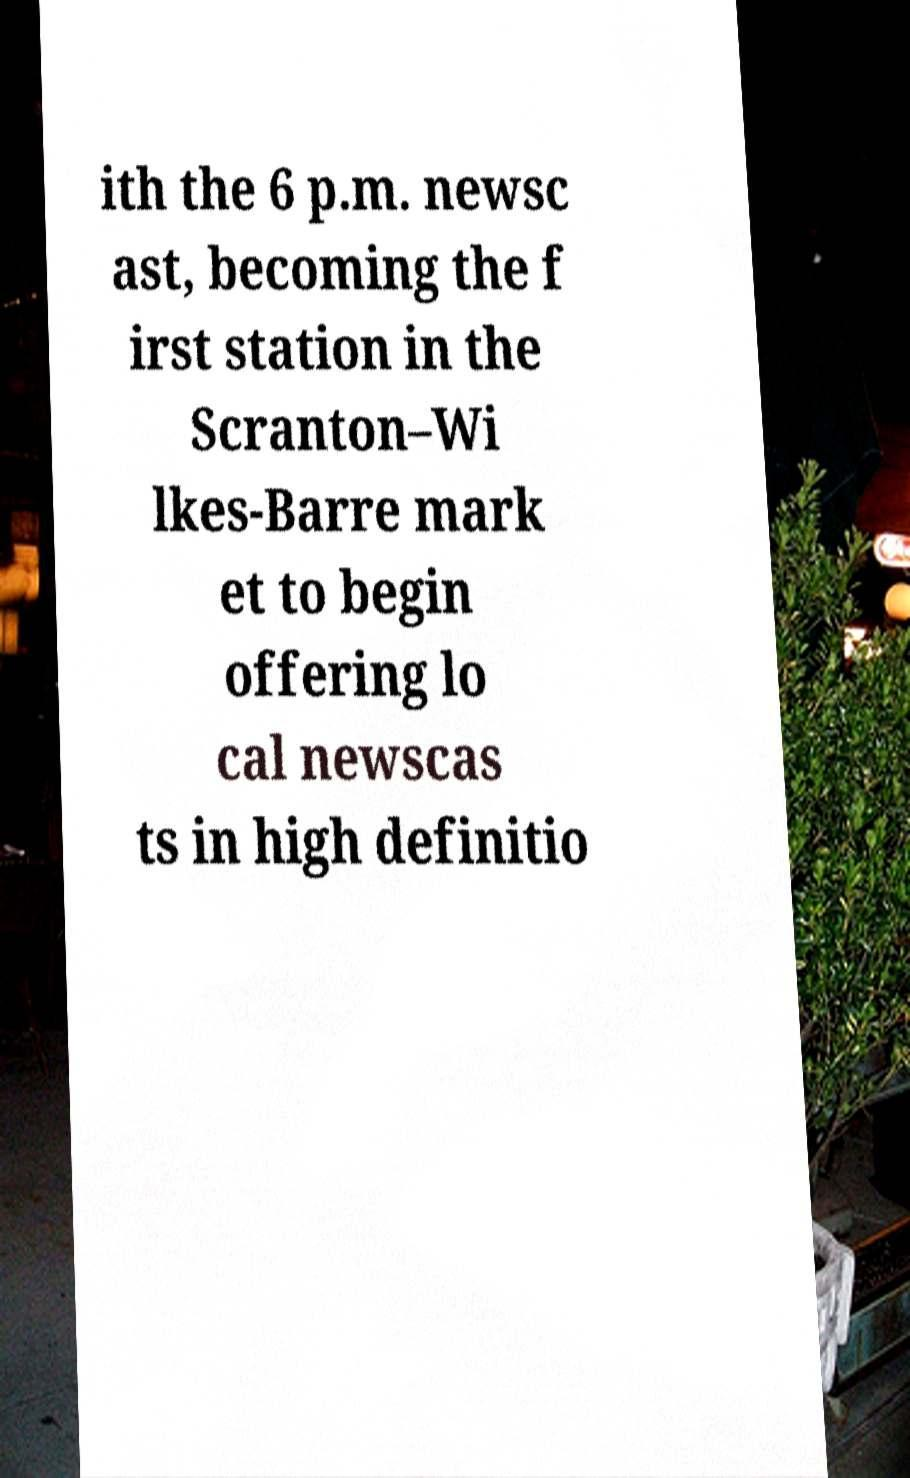I need the written content from this picture converted into text. Can you do that? ith the 6 p.m. newsc ast, becoming the f irst station in the Scranton–Wi lkes-Barre mark et to begin offering lo cal newscas ts in high definitio 